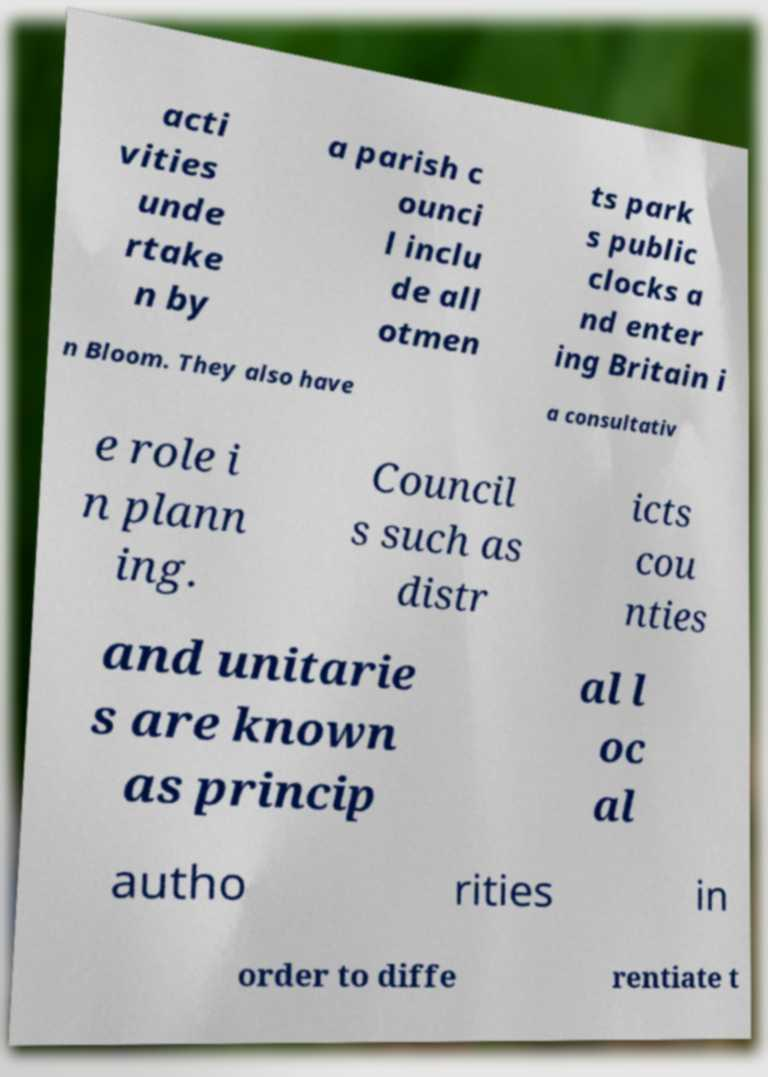Can you read and provide the text displayed in the image?This photo seems to have some interesting text. Can you extract and type it out for me? acti vities unde rtake n by a parish c ounci l inclu de all otmen ts park s public clocks a nd enter ing Britain i n Bloom. They also have a consultativ e role i n plann ing. Council s such as distr icts cou nties and unitarie s are known as princip al l oc al autho rities in order to diffe rentiate t 